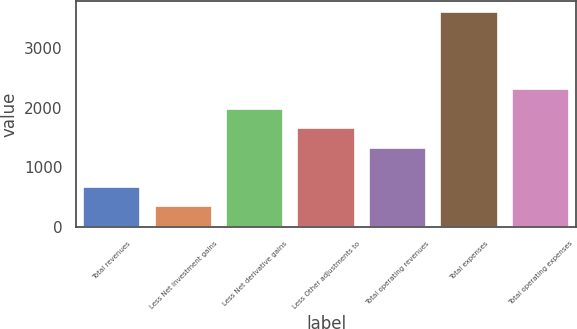<chart> <loc_0><loc_0><loc_500><loc_500><bar_chart><fcel>Total revenues<fcel>Less Net investment gains<fcel>Less Net derivative gains<fcel>Less Other adjustments to<fcel>Total operating revenues<fcel>Total expenses<fcel>Total operating expenses<nl><fcel>676.7<fcel>351<fcel>1979.5<fcel>1653.8<fcel>1328.1<fcel>3608<fcel>2305.2<nl></chart> 